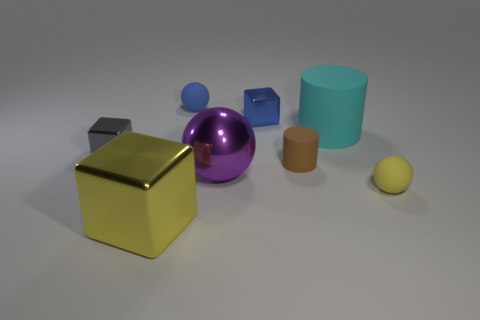Subtract 1 spheres. How many spheres are left? 2 Subtract all rubber spheres. How many spheres are left? 1 Add 2 large gray things. How many objects exist? 10 Subtract all cylinders. How many objects are left? 6 Subtract 0 blue cylinders. How many objects are left? 8 Subtract all gray things. Subtract all big yellow things. How many objects are left? 6 Add 6 large yellow metallic things. How many large yellow metallic things are left? 7 Add 3 yellow spheres. How many yellow spheres exist? 4 